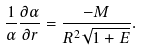<formula> <loc_0><loc_0><loc_500><loc_500>\frac { 1 } { \alpha } \frac { \partial \alpha } { \partial r } = \frac { - M } { R ^ { 2 } \sqrt { 1 + E } } .</formula> 